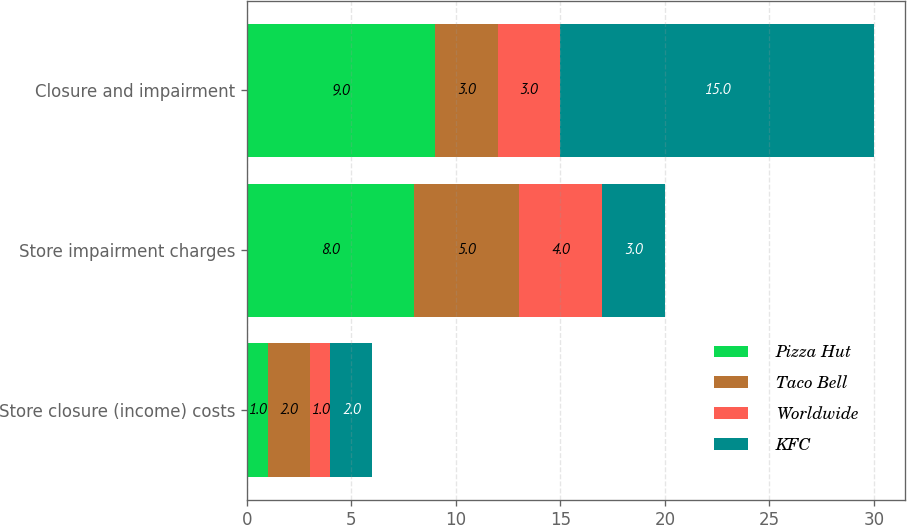Convert chart to OTSL. <chart><loc_0><loc_0><loc_500><loc_500><stacked_bar_chart><ecel><fcel>Store closure (income) costs<fcel>Store impairment charges<fcel>Closure and impairment<nl><fcel>Pizza Hut<fcel>1<fcel>8<fcel>9<nl><fcel>Taco Bell<fcel>2<fcel>5<fcel>3<nl><fcel>Worldwide<fcel>1<fcel>4<fcel>3<nl><fcel>KFC<fcel>2<fcel>3<fcel>15<nl></chart> 